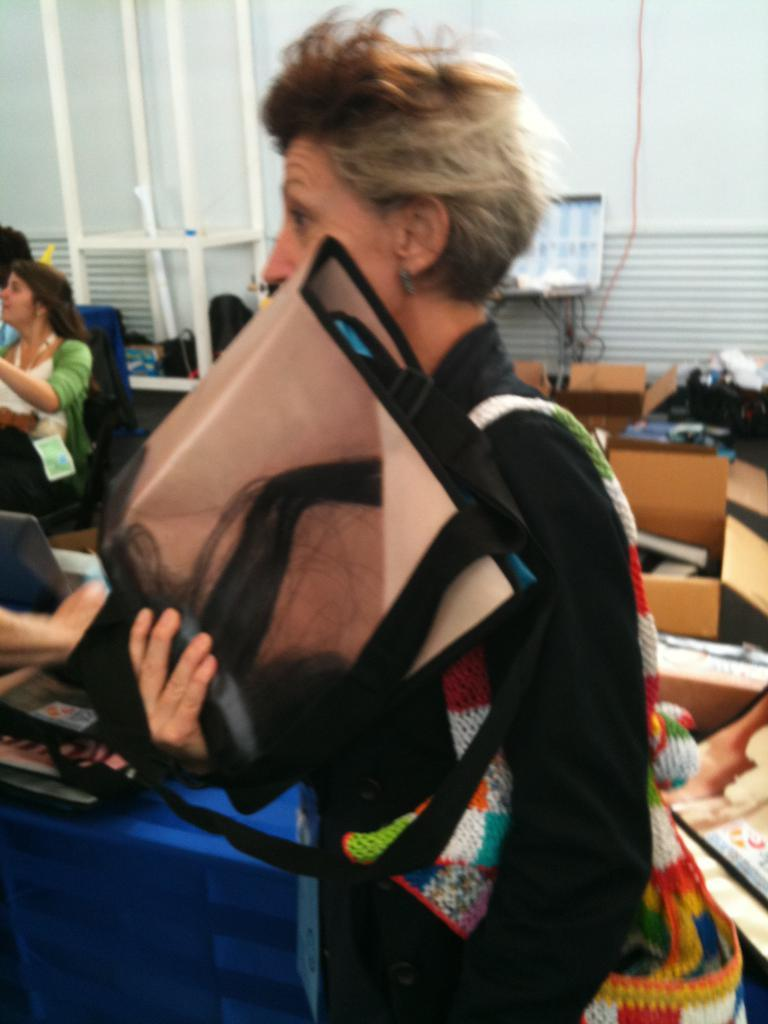What is the main subject in the foreground of the image? There is a person standing in the foreground of the image. What is the person holding in the image? The person is holding a bag. What can be seen in the background of the image? There are people and a box visible in the background of the image. What type of animal is visible in the acoustics or soundproofing in the image? There is no mention of any animal or information about wall acoustics or soundproofing in the image. 